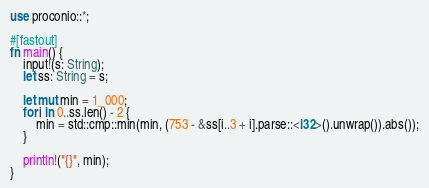<code> <loc_0><loc_0><loc_500><loc_500><_Rust_>use proconio::*;

#[fastout]
fn main() {
    input!(s: String);
    let ss: String = s;

    let mut min = 1_000;
    for i in 0..ss.len() - 2 {
        min = std::cmp::min(min, (753 - &ss[i..3 + i].parse::<i32>().unwrap()).abs());
    }

    println!("{}", min);
}
</code> 